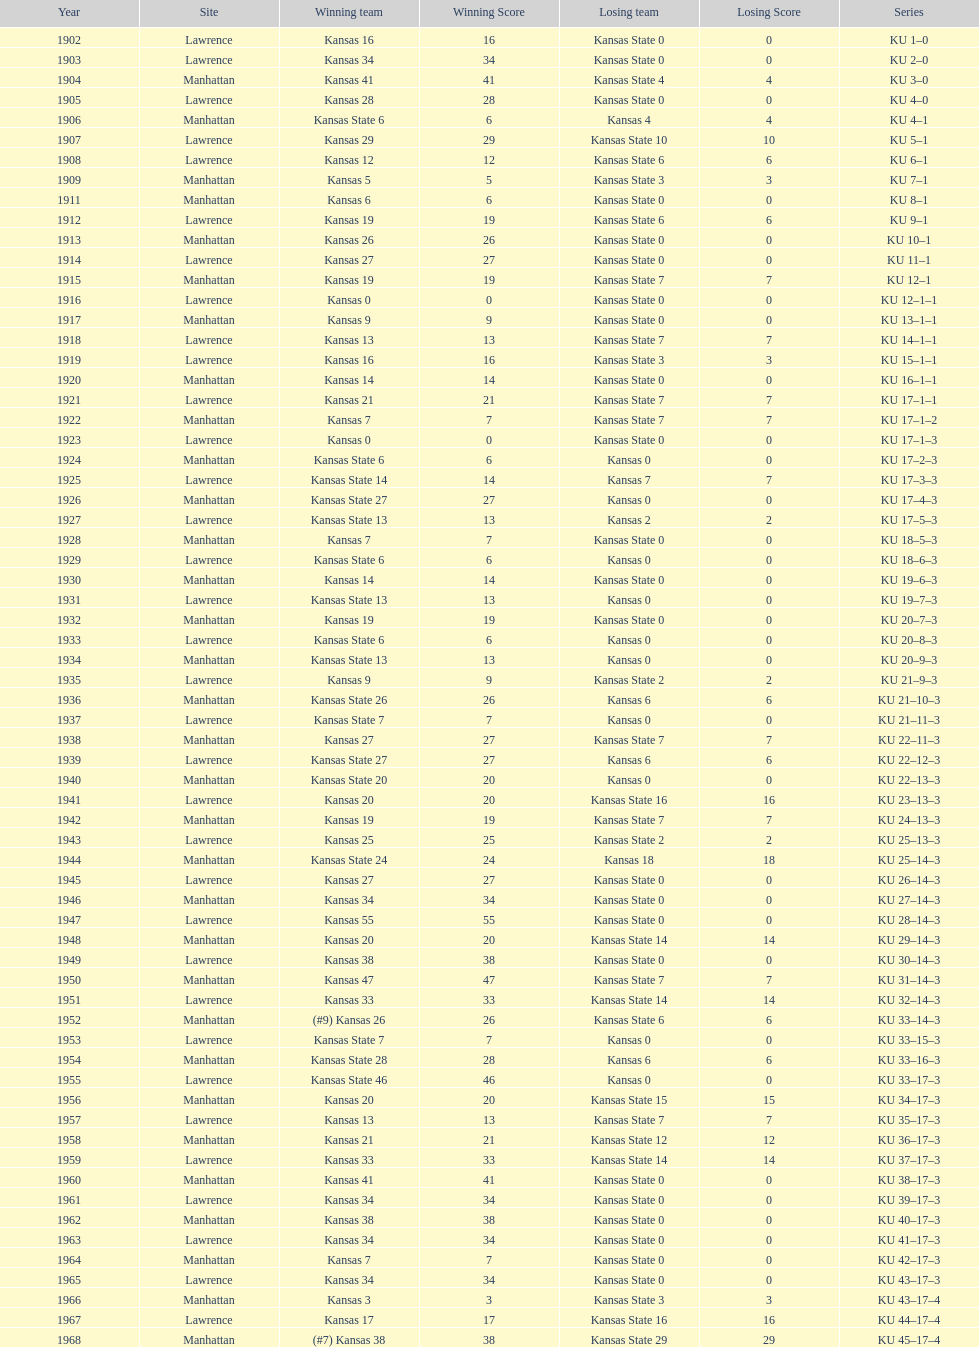How many times did kansas state not score at all against kansas from 1902-1968? 23. 